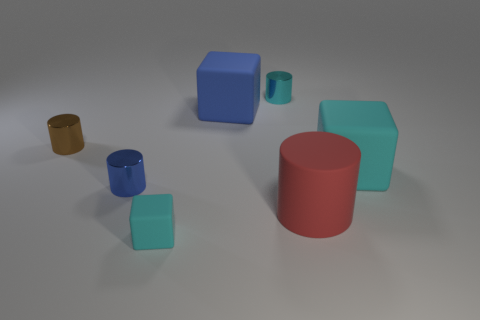Are there any small cylinders that have the same color as the tiny cube?
Offer a very short reply. Yes. There is a tiny cylinder on the right side of the small blue cylinder; is its color the same as the tiny rubber cube?
Provide a short and direct response. Yes. There is a tiny rubber block; is its color the same as the matte block right of the big red cylinder?
Provide a succinct answer. Yes. There is a tiny cyan object in front of the big cyan cube; what shape is it?
Make the answer very short. Cube. Is there any other thing of the same color as the tiny matte object?
Keep it short and to the point. Yes. Are there fewer small cylinders left of the tiny cyan cylinder than shiny things?
Make the answer very short. Yes. How many green metal things are the same size as the blue block?
Give a very brief answer. 0. The rubber thing that is the same color as the tiny cube is what shape?
Give a very brief answer. Cube. What shape is the small thing that is in front of the blue cylinder in front of the small brown shiny cylinder that is behind the rubber cylinder?
Provide a succinct answer. Cube. There is a rubber block that is to the left of the blue rubber object; what color is it?
Your answer should be very brief. Cyan. 